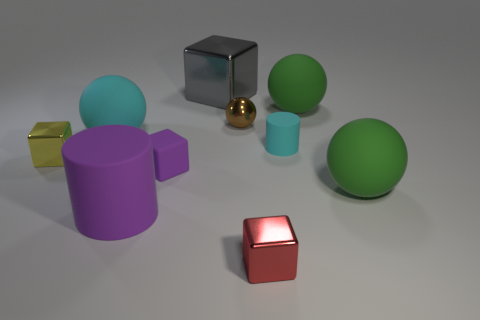How many objects are either small objects that are behind the tiny yellow metallic thing or small things?
Offer a terse response. 5. There is a metal cube that is to the left of the small purple rubber object; does it have the same color as the small matte cube?
Your response must be concise. No. How many other things are there of the same color as the metallic sphere?
Your response must be concise. 0. What number of big objects are either metal objects or brown metallic things?
Offer a terse response. 1. Are there more big purple cylinders than large red metallic things?
Provide a short and direct response. Yes. Are the tiny red thing and the cyan sphere made of the same material?
Give a very brief answer. No. Is there anything else that is made of the same material as the big cyan thing?
Your answer should be compact. Yes. Are there more big rubber spheres that are behind the large block than large metallic objects?
Make the answer very short. No. Do the small rubber cube and the tiny metal ball have the same color?
Give a very brief answer. No. How many tiny brown objects are the same shape as the big metal object?
Offer a very short reply. 0. 